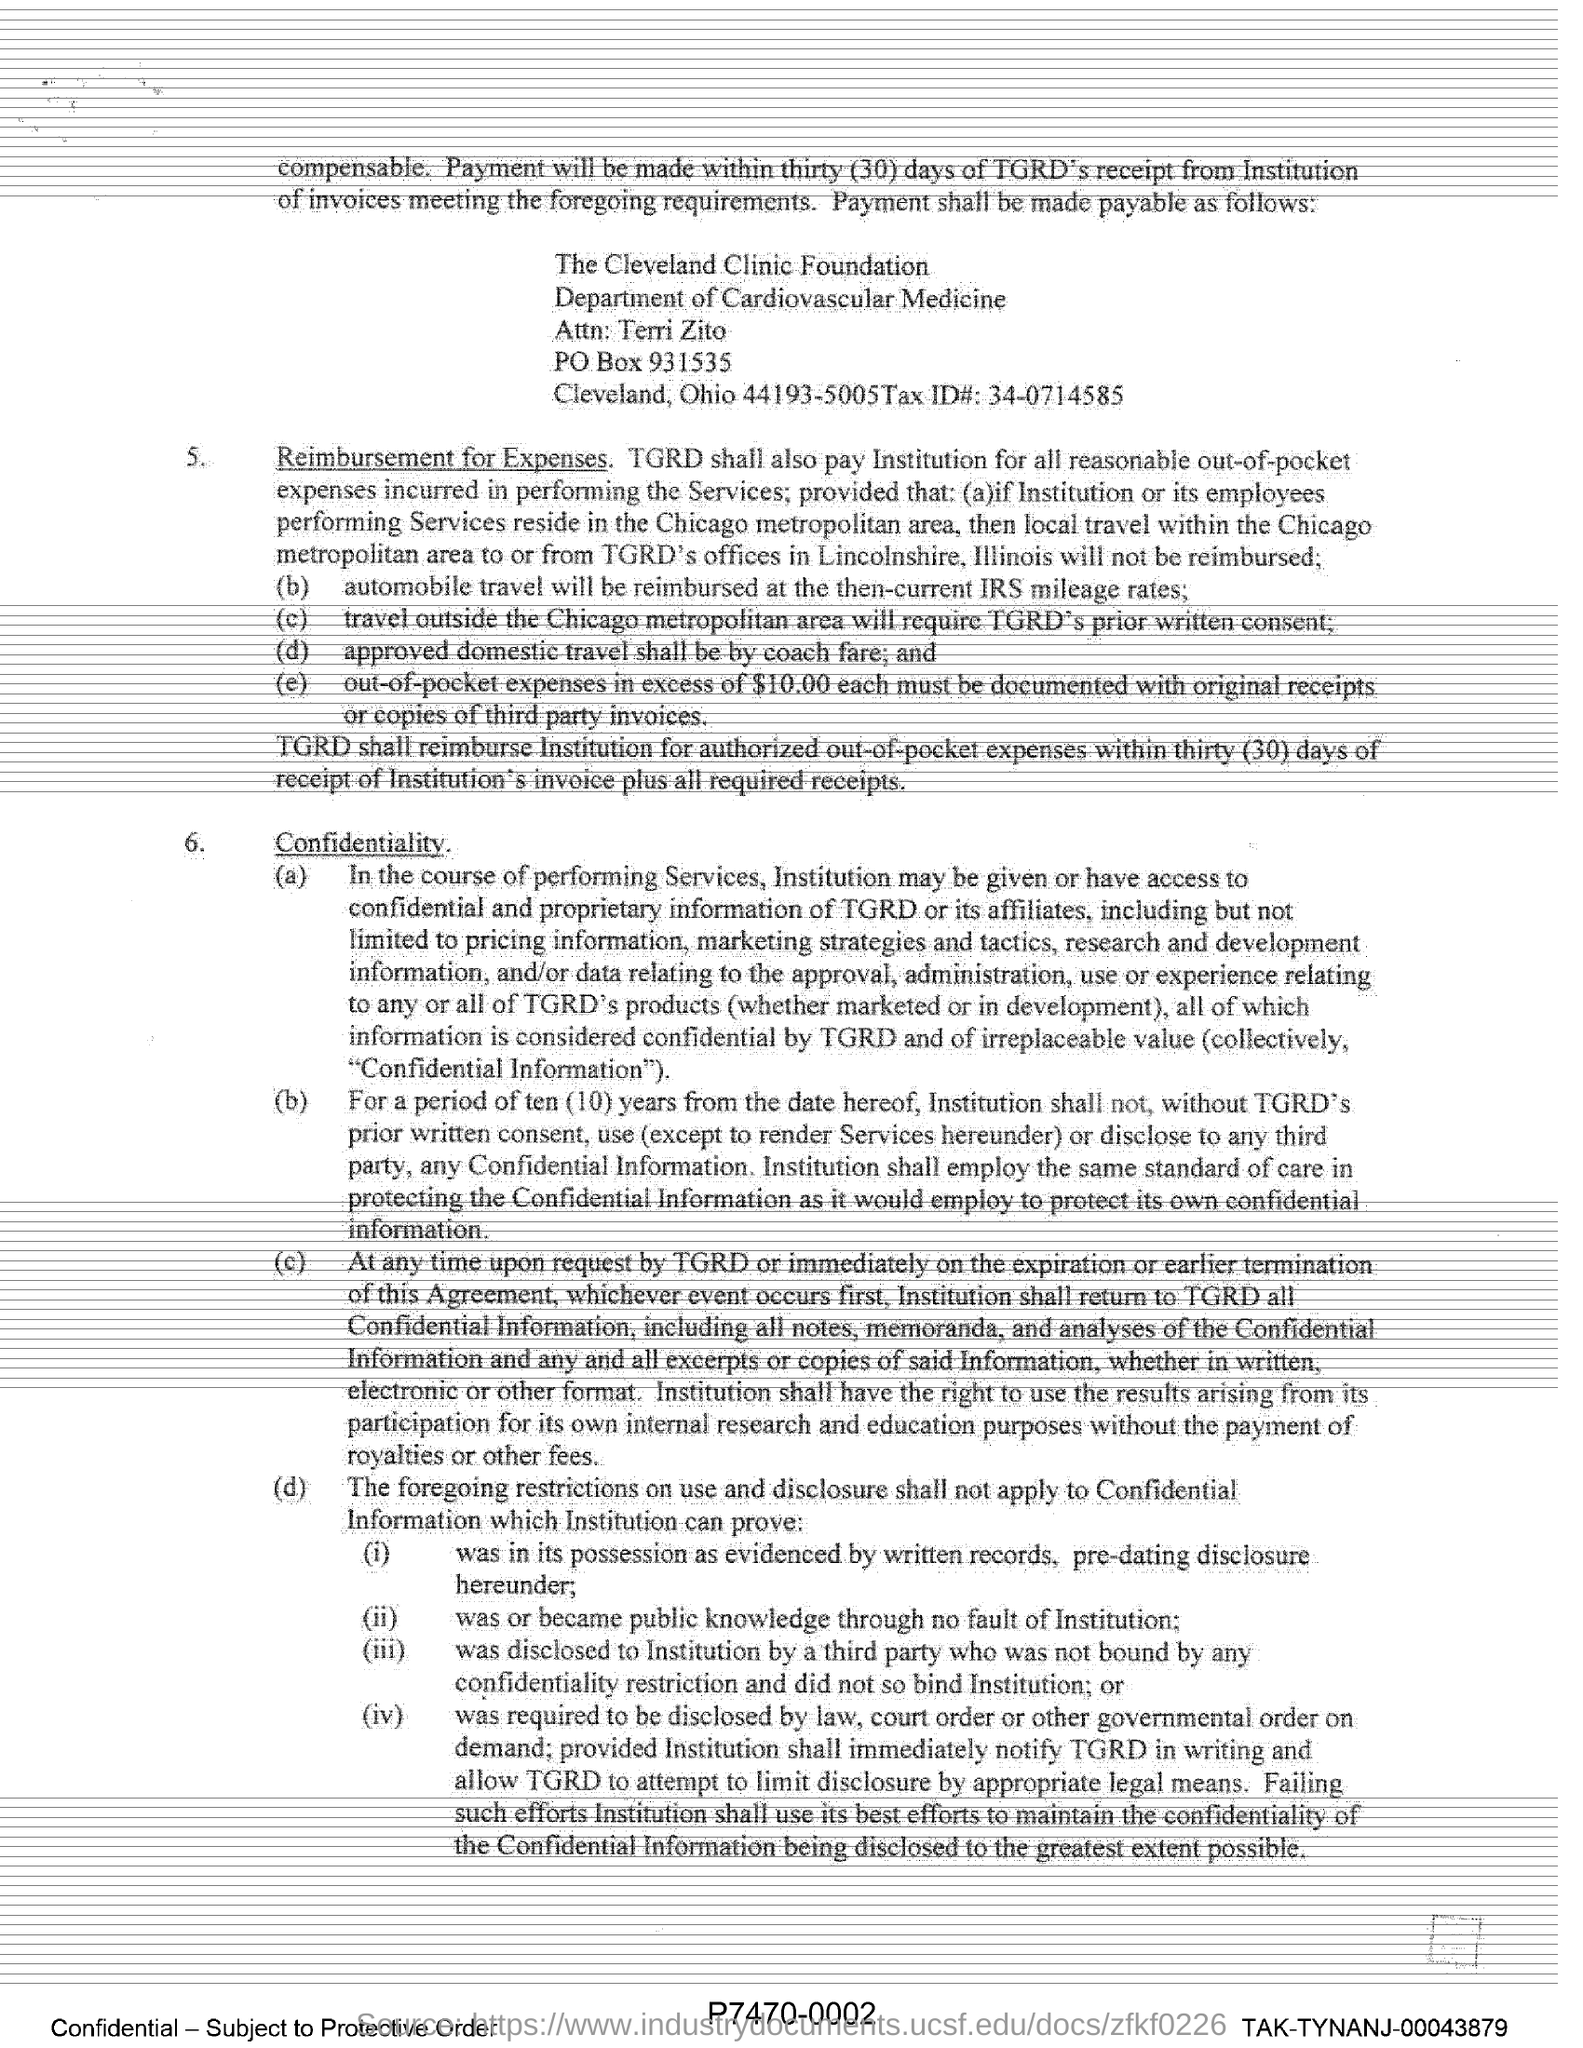Outline some significant characteristics in this image. The Cleveland Clinic Foundation is mentioned in this document. What is the Tax ID mentioned in this document? It is 34-0714585.. The Cleveland Clinic Foundation operates under the Department of Cardiovascular Medicine. The PO Box number is 931535. 